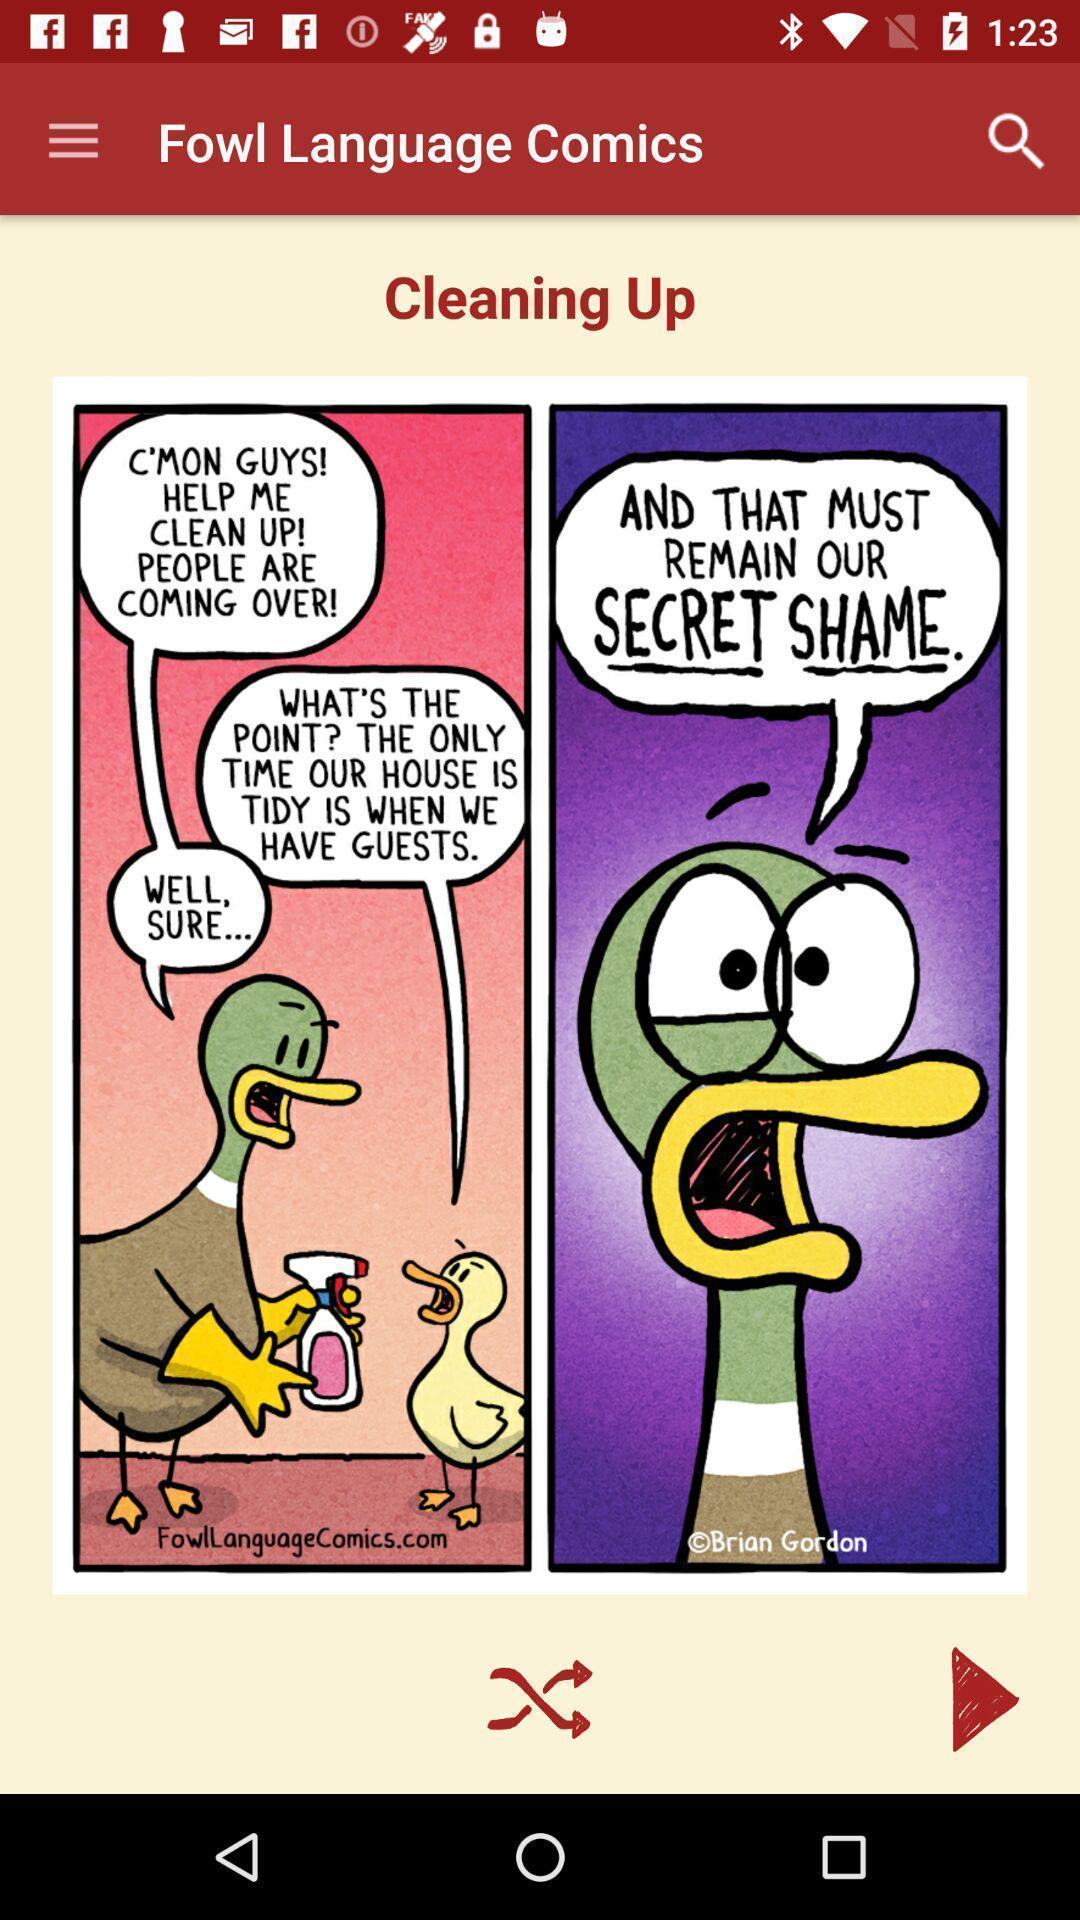Give me a narrative description of this picture. Page showing comic on an app. 